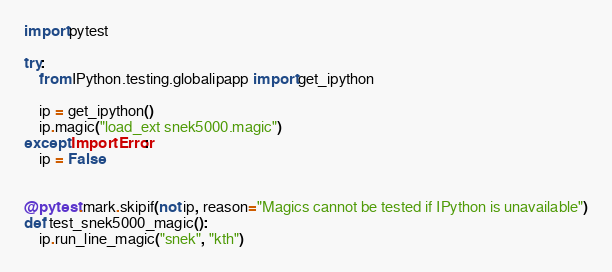<code> <loc_0><loc_0><loc_500><loc_500><_Python_>import pytest

try:
    from IPython.testing.globalipapp import get_ipython

    ip = get_ipython()
    ip.magic("load_ext snek5000.magic")
except ImportError:
    ip = False


@pytest.mark.skipif(not ip, reason="Magics cannot be tested if IPython is unavailable")
def test_snek5000_magic():
    ip.run_line_magic("snek", "kth")
</code> 